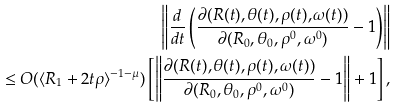Convert formula to latex. <formula><loc_0><loc_0><loc_500><loc_500>\left \| \frac { d } { d t } \left ( \frac { \partial ( R ( t ) , \theta ( t ) , \rho ( t ) , \omega ( t ) ) } { \partial ( R _ { 0 } , \theta _ { 0 } , \rho ^ { 0 } , \omega ^ { 0 } ) } - 1 \right ) \right \| \\ \leq O ( \langle R _ { 1 } + 2 t \rho \rangle ^ { - 1 - \mu } ) \left [ \left \| \frac { \partial ( R ( t ) , \theta ( t ) , \rho ( t ) , \omega ( t ) ) } { \partial ( R _ { 0 } , \theta _ { 0 } , \rho ^ { 0 } , \omega ^ { 0 } ) } - 1 \right \| + 1 \right ] ,</formula> 